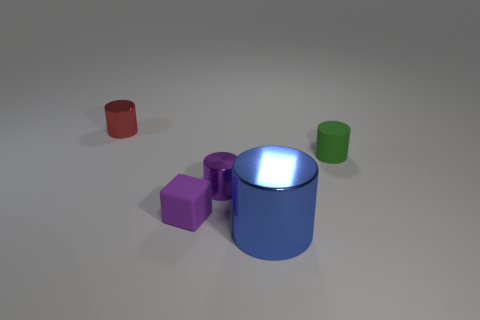Are there any other things that have the same size as the cube?
Your response must be concise. Yes. There is a cylinder that is the same material as the small purple cube; what is its color?
Keep it short and to the point. Green. What number of cubes are either purple objects or large blue rubber objects?
Keep it short and to the point. 1. What number of objects are either small metal cylinders or tiny things to the right of the tiny red cylinder?
Keep it short and to the point. 4. Is there a big blue block?
Keep it short and to the point. No. What number of other large things are the same color as the large object?
Your answer should be compact. 0. What is the material of the object that is the same color as the tiny matte block?
Offer a terse response. Metal. What size is the shiny thing that is left of the small metal cylinder to the right of the tiny red metallic object?
Your answer should be compact. Small. Is there a tiny green object made of the same material as the tiny cube?
Your answer should be very brief. Yes. There is a purple cylinder that is the same size as the matte block; what is it made of?
Make the answer very short. Metal. 